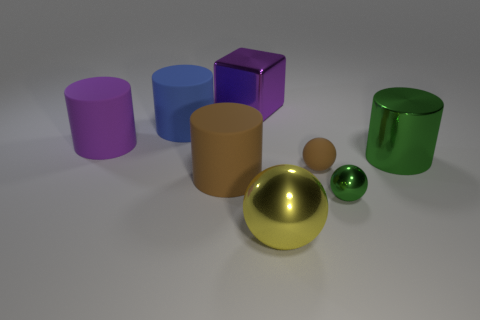How many cylinders are to the left of the large brown object? 2 